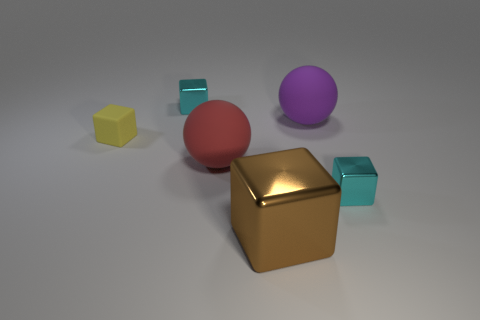How many cyan blocks must be subtracted to get 1 cyan blocks? 1 Subtract all brown blocks. How many blocks are left? 3 Add 2 large brown objects. How many objects exist? 8 Add 3 red rubber things. How many red rubber things are left? 4 Add 3 large yellow cubes. How many large yellow cubes exist? 3 Subtract all red balls. How many balls are left? 1 Subtract 0 gray spheres. How many objects are left? 6 Subtract all cubes. How many objects are left? 2 Subtract 2 blocks. How many blocks are left? 2 Subtract all green balls. Subtract all green blocks. How many balls are left? 2 